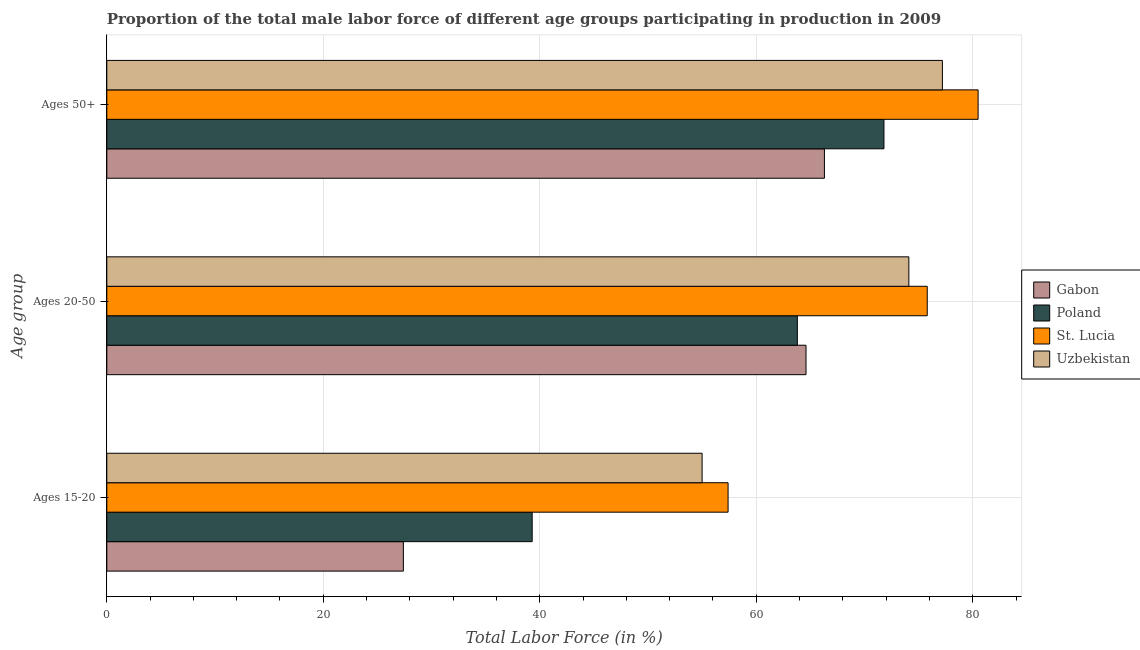How many different coloured bars are there?
Your answer should be very brief. 4. How many groups of bars are there?
Keep it short and to the point. 3. Are the number of bars per tick equal to the number of legend labels?
Your response must be concise. Yes. How many bars are there on the 1st tick from the top?
Provide a succinct answer. 4. How many bars are there on the 3rd tick from the bottom?
Offer a terse response. 4. What is the label of the 2nd group of bars from the top?
Your answer should be very brief. Ages 20-50. What is the percentage of male labor force above age 50 in Poland?
Your response must be concise. 71.8. Across all countries, what is the maximum percentage of male labor force above age 50?
Make the answer very short. 80.5. Across all countries, what is the minimum percentage of male labor force above age 50?
Ensure brevity in your answer.  66.3. In which country was the percentage of male labor force above age 50 maximum?
Ensure brevity in your answer.  St. Lucia. In which country was the percentage of male labor force above age 50 minimum?
Provide a succinct answer. Gabon. What is the total percentage of male labor force within the age group 15-20 in the graph?
Offer a very short reply. 179.1. What is the difference between the percentage of male labor force within the age group 15-20 in Uzbekistan and that in St. Lucia?
Provide a short and direct response. -2.4. What is the difference between the percentage of male labor force above age 50 in St. Lucia and the percentage of male labor force within the age group 20-50 in Uzbekistan?
Your answer should be very brief. 6.4. What is the average percentage of male labor force within the age group 20-50 per country?
Keep it short and to the point. 69.57. What is the difference between the percentage of male labor force above age 50 and percentage of male labor force within the age group 15-20 in St. Lucia?
Your answer should be very brief. 23.1. In how many countries, is the percentage of male labor force within the age group 15-20 greater than 20 %?
Give a very brief answer. 4. What is the ratio of the percentage of male labor force within the age group 15-20 in Poland to that in Uzbekistan?
Keep it short and to the point. 0.71. Is the percentage of male labor force above age 50 in Gabon less than that in Uzbekistan?
Provide a short and direct response. Yes. Is the difference between the percentage of male labor force above age 50 in Uzbekistan and Gabon greater than the difference between the percentage of male labor force within the age group 15-20 in Uzbekistan and Gabon?
Ensure brevity in your answer.  No. What is the difference between the highest and the second highest percentage of male labor force above age 50?
Make the answer very short. 3.3. What is the difference between the highest and the lowest percentage of male labor force within the age group 20-50?
Offer a very short reply. 12. Is the sum of the percentage of male labor force above age 50 in Gabon and St. Lucia greater than the maximum percentage of male labor force within the age group 20-50 across all countries?
Keep it short and to the point. Yes. How many bars are there?
Your answer should be very brief. 12. Are all the bars in the graph horizontal?
Offer a very short reply. Yes. How many countries are there in the graph?
Provide a short and direct response. 4. Are the values on the major ticks of X-axis written in scientific E-notation?
Keep it short and to the point. No. Does the graph contain grids?
Provide a short and direct response. Yes. How many legend labels are there?
Offer a very short reply. 4. How are the legend labels stacked?
Offer a terse response. Vertical. What is the title of the graph?
Provide a succinct answer. Proportion of the total male labor force of different age groups participating in production in 2009. What is the label or title of the Y-axis?
Your answer should be compact. Age group. What is the Total Labor Force (in %) in Gabon in Ages 15-20?
Your response must be concise. 27.4. What is the Total Labor Force (in %) in Poland in Ages 15-20?
Your response must be concise. 39.3. What is the Total Labor Force (in %) in St. Lucia in Ages 15-20?
Keep it short and to the point. 57.4. What is the Total Labor Force (in %) of Uzbekistan in Ages 15-20?
Your answer should be very brief. 55. What is the Total Labor Force (in %) of Gabon in Ages 20-50?
Ensure brevity in your answer.  64.6. What is the Total Labor Force (in %) of Poland in Ages 20-50?
Provide a succinct answer. 63.8. What is the Total Labor Force (in %) of St. Lucia in Ages 20-50?
Provide a short and direct response. 75.8. What is the Total Labor Force (in %) in Uzbekistan in Ages 20-50?
Ensure brevity in your answer.  74.1. What is the Total Labor Force (in %) of Gabon in Ages 50+?
Keep it short and to the point. 66.3. What is the Total Labor Force (in %) in Poland in Ages 50+?
Make the answer very short. 71.8. What is the Total Labor Force (in %) of St. Lucia in Ages 50+?
Your response must be concise. 80.5. What is the Total Labor Force (in %) in Uzbekistan in Ages 50+?
Your answer should be compact. 77.2. Across all Age group, what is the maximum Total Labor Force (in %) of Gabon?
Keep it short and to the point. 66.3. Across all Age group, what is the maximum Total Labor Force (in %) of Poland?
Make the answer very short. 71.8. Across all Age group, what is the maximum Total Labor Force (in %) of St. Lucia?
Make the answer very short. 80.5. Across all Age group, what is the maximum Total Labor Force (in %) in Uzbekistan?
Your answer should be compact. 77.2. Across all Age group, what is the minimum Total Labor Force (in %) in Gabon?
Keep it short and to the point. 27.4. Across all Age group, what is the minimum Total Labor Force (in %) in Poland?
Keep it short and to the point. 39.3. Across all Age group, what is the minimum Total Labor Force (in %) of St. Lucia?
Your answer should be compact. 57.4. What is the total Total Labor Force (in %) of Gabon in the graph?
Give a very brief answer. 158.3. What is the total Total Labor Force (in %) of Poland in the graph?
Give a very brief answer. 174.9. What is the total Total Labor Force (in %) in St. Lucia in the graph?
Provide a short and direct response. 213.7. What is the total Total Labor Force (in %) in Uzbekistan in the graph?
Ensure brevity in your answer.  206.3. What is the difference between the Total Labor Force (in %) in Gabon in Ages 15-20 and that in Ages 20-50?
Offer a very short reply. -37.2. What is the difference between the Total Labor Force (in %) in Poland in Ages 15-20 and that in Ages 20-50?
Give a very brief answer. -24.5. What is the difference between the Total Labor Force (in %) of St. Lucia in Ages 15-20 and that in Ages 20-50?
Offer a terse response. -18.4. What is the difference between the Total Labor Force (in %) of Uzbekistan in Ages 15-20 and that in Ages 20-50?
Offer a terse response. -19.1. What is the difference between the Total Labor Force (in %) in Gabon in Ages 15-20 and that in Ages 50+?
Keep it short and to the point. -38.9. What is the difference between the Total Labor Force (in %) in Poland in Ages 15-20 and that in Ages 50+?
Give a very brief answer. -32.5. What is the difference between the Total Labor Force (in %) of St. Lucia in Ages 15-20 and that in Ages 50+?
Your response must be concise. -23.1. What is the difference between the Total Labor Force (in %) of Uzbekistan in Ages 15-20 and that in Ages 50+?
Provide a succinct answer. -22.2. What is the difference between the Total Labor Force (in %) in Poland in Ages 20-50 and that in Ages 50+?
Provide a succinct answer. -8. What is the difference between the Total Labor Force (in %) of Gabon in Ages 15-20 and the Total Labor Force (in %) of Poland in Ages 20-50?
Provide a succinct answer. -36.4. What is the difference between the Total Labor Force (in %) of Gabon in Ages 15-20 and the Total Labor Force (in %) of St. Lucia in Ages 20-50?
Give a very brief answer. -48.4. What is the difference between the Total Labor Force (in %) in Gabon in Ages 15-20 and the Total Labor Force (in %) in Uzbekistan in Ages 20-50?
Keep it short and to the point. -46.7. What is the difference between the Total Labor Force (in %) in Poland in Ages 15-20 and the Total Labor Force (in %) in St. Lucia in Ages 20-50?
Make the answer very short. -36.5. What is the difference between the Total Labor Force (in %) in Poland in Ages 15-20 and the Total Labor Force (in %) in Uzbekistan in Ages 20-50?
Provide a short and direct response. -34.8. What is the difference between the Total Labor Force (in %) of St. Lucia in Ages 15-20 and the Total Labor Force (in %) of Uzbekistan in Ages 20-50?
Ensure brevity in your answer.  -16.7. What is the difference between the Total Labor Force (in %) of Gabon in Ages 15-20 and the Total Labor Force (in %) of Poland in Ages 50+?
Make the answer very short. -44.4. What is the difference between the Total Labor Force (in %) of Gabon in Ages 15-20 and the Total Labor Force (in %) of St. Lucia in Ages 50+?
Your answer should be compact. -53.1. What is the difference between the Total Labor Force (in %) of Gabon in Ages 15-20 and the Total Labor Force (in %) of Uzbekistan in Ages 50+?
Make the answer very short. -49.8. What is the difference between the Total Labor Force (in %) of Poland in Ages 15-20 and the Total Labor Force (in %) of St. Lucia in Ages 50+?
Offer a terse response. -41.2. What is the difference between the Total Labor Force (in %) in Poland in Ages 15-20 and the Total Labor Force (in %) in Uzbekistan in Ages 50+?
Your answer should be compact. -37.9. What is the difference between the Total Labor Force (in %) of St. Lucia in Ages 15-20 and the Total Labor Force (in %) of Uzbekistan in Ages 50+?
Your answer should be very brief. -19.8. What is the difference between the Total Labor Force (in %) in Gabon in Ages 20-50 and the Total Labor Force (in %) in Poland in Ages 50+?
Your answer should be compact. -7.2. What is the difference between the Total Labor Force (in %) of Gabon in Ages 20-50 and the Total Labor Force (in %) of St. Lucia in Ages 50+?
Ensure brevity in your answer.  -15.9. What is the difference between the Total Labor Force (in %) of Gabon in Ages 20-50 and the Total Labor Force (in %) of Uzbekistan in Ages 50+?
Your answer should be very brief. -12.6. What is the difference between the Total Labor Force (in %) in Poland in Ages 20-50 and the Total Labor Force (in %) in St. Lucia in Ages 50+?
Provide a succinct answer. -16.7. What is the average Total Labor Force (in %) in Gabon per Age group?
Offer a terse response. 52.77. What is the average Total Labor Force (in %) in Poland per Age group?
Your answer should be compact. 58.3. What is the average Total Labor Force (in %) of St. Lucia per Age group?
Provide a succinct answer. 71.23. What is the average Total Labor Force (in %) in Uzbekistan per Age group?
Offer a very short reply. 68.77. What is the difference between the Total Labor Force (in %) of Gabon and Total Labor Force (in %) of Poland in Ages 15-20?
Keep it short and to the point. -11.9. What is the difference between the Total Labor Force (in %) in Gabon and Total Labor Force (in %) in St. Lucia in Ages 15-20?
Provide a short and direct response. -30. What is the difference between the Total Labor Force (in %) of Gabon and Total Labor Force (in %) of Uzbekistan in Ages 15-20?
Offer a very short reply. -27.6. What is the difference between the Total Labor Force (in %) of Poland and Total Labor Force (in %) of St. Lucia in Ages 15-20?
Provide a short and direct response. -18.1. What is the difference between the Total Labor Force (in %) of Poland and Total Labor Force (in %) of Uzbekistan in Ages 15-20?
Keep it short and to the point. -15.7. What is the difference between the Total Labor Force (in %) of St. Lucia and Total Labor Force (in %) of Uzbekistan in Ages 15-20?
Offer a very short reply. 2.4. What is the difference between the Total Labor Force (in %) in Gabon and Total Labor Force (in %) in Uzbekistan in Ages 20-50?
Offer a terse response. -9.5. What is the difference between the Total Labor Force (in %) of Poland and Total Labor Force (in %) of Uzbekistan in Ages 20-50?
Provide a short and direct response. -10.3. What is the difference between the Total Labor Force (in %) in St. Lucia and Total Labor Force (in %) in Uzbekistan in Ages 20-50?
Your answer should be compact. 1.7. What is the difference between the Total Labor Force (in %) in Poland and Total Labor Force (in %) in Uzbekistan in Ages 50+?
Provide a succinct answer. -5.4. What is the ratio of the Total Labor Force (in %) in Gabon in Ages 15-20 to that in Ages 20-50?
Provide a short and direct response. 0.42. What is the ratio of the Total Labor Force (in %) in Poland in Ages 15-20 to that in Ages 20-50?
Keep it short and to the point. 0.62. What is the ratio of the Total Labor Force (in %) of St. Lucia in Ages 15-20 to that in Ages 20-50?
Your answer should be very brief. 0.76. What is the ratio of the Total Labor Force (in %) of Uzbekistan in Ages 15-20 to that in Ages 20-50?
Offer a terse response. 0.74. What is the ratio of the Total Labor Force (in %) of Gabon in Ages 15-20 to that in Ages 50+?
Keep it short and to the point. 0.41. What is the ratio of the Total Labor Force (in %) in Poland in Ages 15-20 to that in Ages 50+?
Keep it short and to the point. 0.55. What is the ratio of the Total Labor Force (in %) of St. Lucia in Ages 15-20 to that in Ages 50+?
Your answer should be compact. 0.71. What is the ratio of the Total Labor Force (in %) of Uzbekistan in Ages 15-20 to that in Ages 50+?
Provide a short and direct response. 0.71. What is the ratio of the Total Labor Force (in %) in Gabon in Ages 20-50 to that in Ages 50+?
Your answer should be compact. 0.97. What is the ratio of the Total Labor Force (in %) of Poland in Ages 20-50 to that in Ages 50+?
Ensure brevity in your answer.  0.89. What is the ratio of the Total Labor Force (in %) in St. Lucia in Ages 20-50 to that in Ages 50+?
Give a very brief answer. 0.94. What is the ratio of the Total Labor Force (in %) in Uzbekistan in Ages 20-50 to that in Ages 50+?
Offer a terse response. 0.96. What is the difference between the highest and the second highest Total Labor Force (in %) of Gabon?
Give a very brief answer. 1.7. What is the difference between the highest and the second highest Total Labor Force (in %) in Poland?
Provide a short and direct response. 8. What is the difference between the highest and the lowest Total Labor Force (in %) of Gabon?
Offer a very short reply. 38.9. What is the difference between the highest and the lowest Total Labor Force (in %) in Poland?
Provide a succinct answer. 32.5. What is the difference between the highest and the lowest Total Labor Force (in %) of St. Lucia?
Your response must be concise. 23.1. What is the difference between the highest and the lowest Total Labor Force (in %) of Uzbekistan?
Make the answer very short. 22.2. 